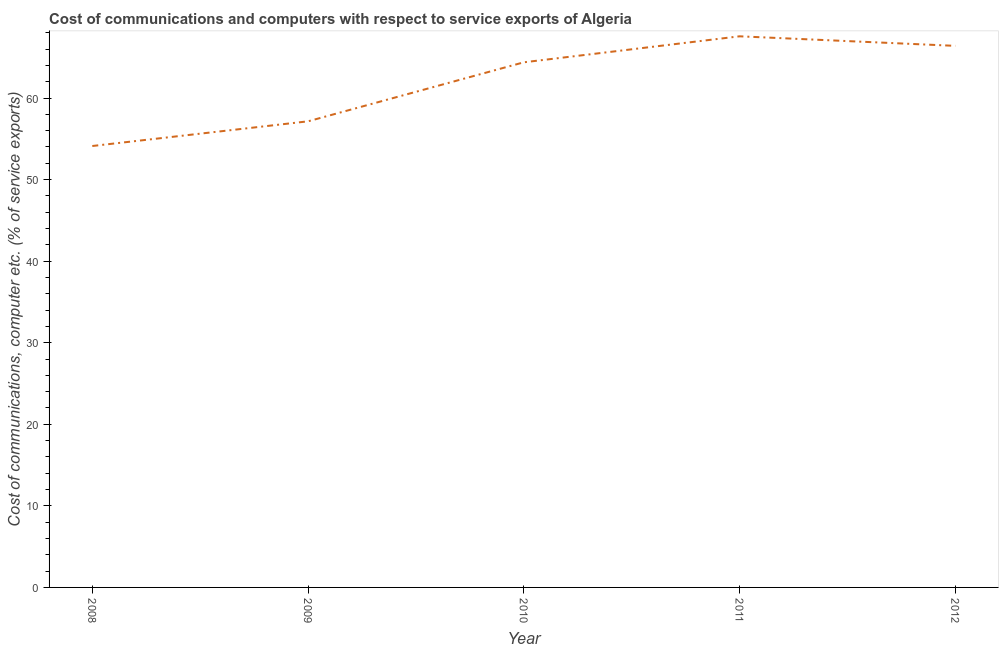What is the cost of communications and computer in 2008?
Provide a succinct answer. 54.12. Across all years, what is the maximum cost of communications and computer?
Offer a very short reply. 67.57. Across all years, what is the minimum cost of communications and computer?
Ensure brevity in your answer.  54.12. In which year was the cost of communications and computer maximum?
Your response must be concise. 2011. What is the sum of the cost of communications and computer?
Provide a short and direct response. 309.62. What is the difference between the cost of communications and computer in 2009 and 2010?
Your response must be concise. -7.24. What is the average cost of communications and computer per year?
Your answer should be compact. 61.92. What is the median cost of communications and computer?
Your response must be concise. 64.38. Do a majority of the years between 2011 and 2012 (inclusive) have cost of communications and computer greater than 24 %?
Ensure brevity in your answer.  Yes. What is the ratio of the cost of communications and computer in 2009 to that in 2012?
Keep it short and to the point. 0.86. Is the cost of communications and computer in 2009 less than that in 2010?
Provide a short and direct response. Yes. Is the difference between the cost of communications and computer in 2008 and 2012 greater than the difference between any two years?
Offer a terse response. No. What is the difference between the highest and the second highest cost of communications and computer?
Your response must be concise. 1.17. What is the difference between the highest and the lowest cost of communications and computer?
Offer a very short reply. 13.45. Does the cost of communications and computer monotonically increase over the years?
Your response must be concise. No. How many lines are there?
Make the answer very short. 1. How many years are there in the graph?
Make the answer very short. 5. What is the difference between two consecutive major ticks on the Y-axis?
Make the answer very short. 10. Does the graph contain any zero values?
Give a very brief answer. No. What is the title of the graph?
Provide a short and direct response. Cost of communications and computers with respect to service exports of Algeria. What is the label or title of the Y-axis?
Provide a short and direct response. Cost of communications, computer etc. (% of service exports). What is the Cost of communications, computer etc. (% of service exports) in 2008?
Provide a short and direct response. 54.12. What is the Cost of communications, computer etc. (% of service exports) in 2009?
Offer a terse response. 57.15. What is the Cost of communications, computer etc. (% of service exports) in 2010?
Provide a short and direct response. 64.38. What is the Cost of communications, computer etc. (% of service exports) of 2011?
Keep it short and to the point. 67.57. What is the Cost of communications, computer etc. (% of service exports) in 2012?
Keep it short and to the point. 66.4. What is the difference between the Cost of communications, computer etc. (% of service exports) in 2008 and 2009?
Give a very brief answer. -3.03. What is the difference between the Cost of communications, computer etc. (% of service exports) in 2008 and 2010?
Ensure brevity in your answer.  -10.26. What is the difference between the Cost of communications, computer etc. (% of service exports) in 2008 and 2011?
Your answer should be compact. -13.45. What is the difference between the Cost of communications, computer etc. (% of service exports) in 2008 and 2012?
Your response must be concise. -12.28. What is the difference between the Cost of communications, computer etc. (% of service exports) in 2009 and 2010?
Give a very brief answer. -7.24. What is the difference between the Cost of communications, computer etc. (% of service exports) in 2009 and 2011?
Keep it short and to the point. -10.42. What is the difference between the Cost of communications, computer etc. (% of service exports) in 2009 and 2012?
Give a very brief answer. -9.25. What is the difference between the Cost of communications, computer etc. (% of service exports) in 2010 and 2011?
Offer a terse response. -3.19. What is the difference between the Cost of communications, computer etc. (% of service exports) in 2010 and 2012?
Provide a succinct answer. -2.02. What is the difference between the Cost of communications, computer etc. (% of service exports) in 2011 and 2012?
Your answer should be very brief. 1.17. What is the ratio of the Cost of communications, computer etc. (% of service exports) in 2008 to that in 2009?
Make the answer very short. 0.95. What is the ratio of the Cost of communications, computer etc. (% of service exports) in 2008 to that in 2010?
Ensure brevity in your answer.  0.84. What is the ratio of the Cost of communications, computer etc. (% of service exports) in 2008 to that in 2011?
Your response must be concise. 0.8. What is the ratio of the Cost of communications, computer etc. (% of service exports) in 2008 to that in 2012?
Offer a very short reply. 0.81. What is the ratio of the Cost of communications, computer etc. (% of service exports) in 2009 to that in 2010?
Provide a short and direct response. 0.89. What is the ratio of the Cost of communications, computer etc. (% of service exports) in 2009 to that in 2011?
Make the answer very short. 0.85. What is the ratio of the Cost of communications, computer etc. (% of service exports) in 2009 to that in 2012?
Keep it short and to the point. 0.86. What is the ratio of the Cost of communications, computer etc. (% of service exports) in 2010 to that in 2011?
Your response must be concise. 0.95. 